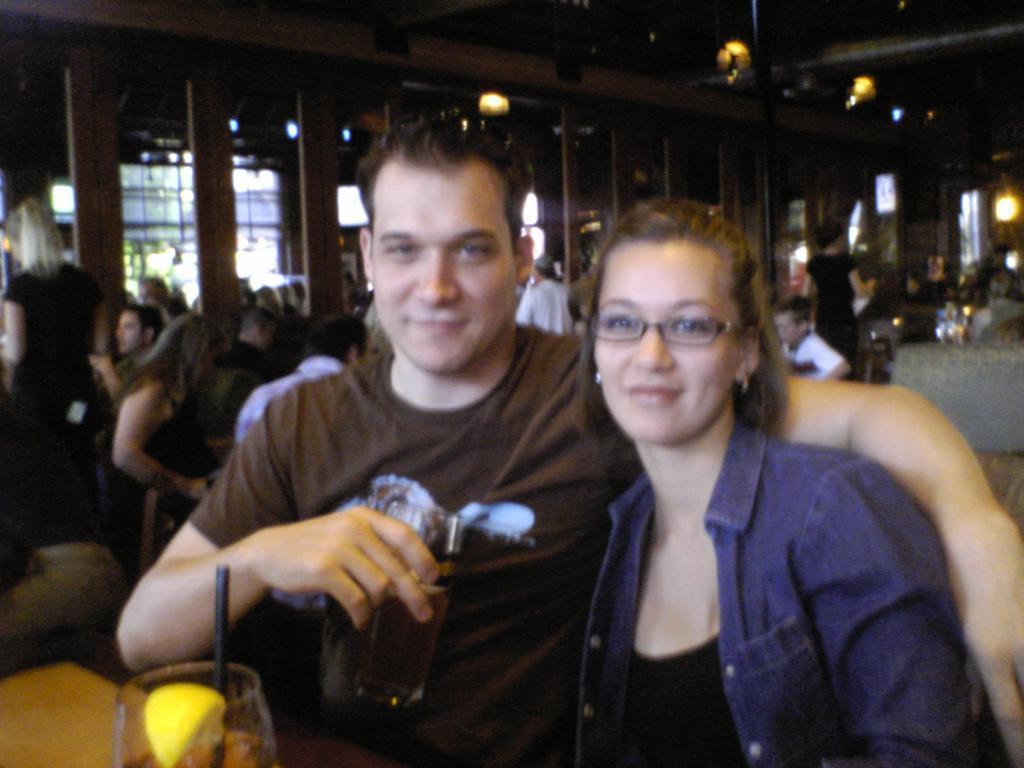Could you give a brief overview of what you see in this image? In this image we can see a man and a woman are sitting on the chairs at the table and the man is holding a glass in the hand and there is a glass with straw in it and a lemon slice on it on the table. In the background there are few persons sitting and standing, lights, screen and other objects. 